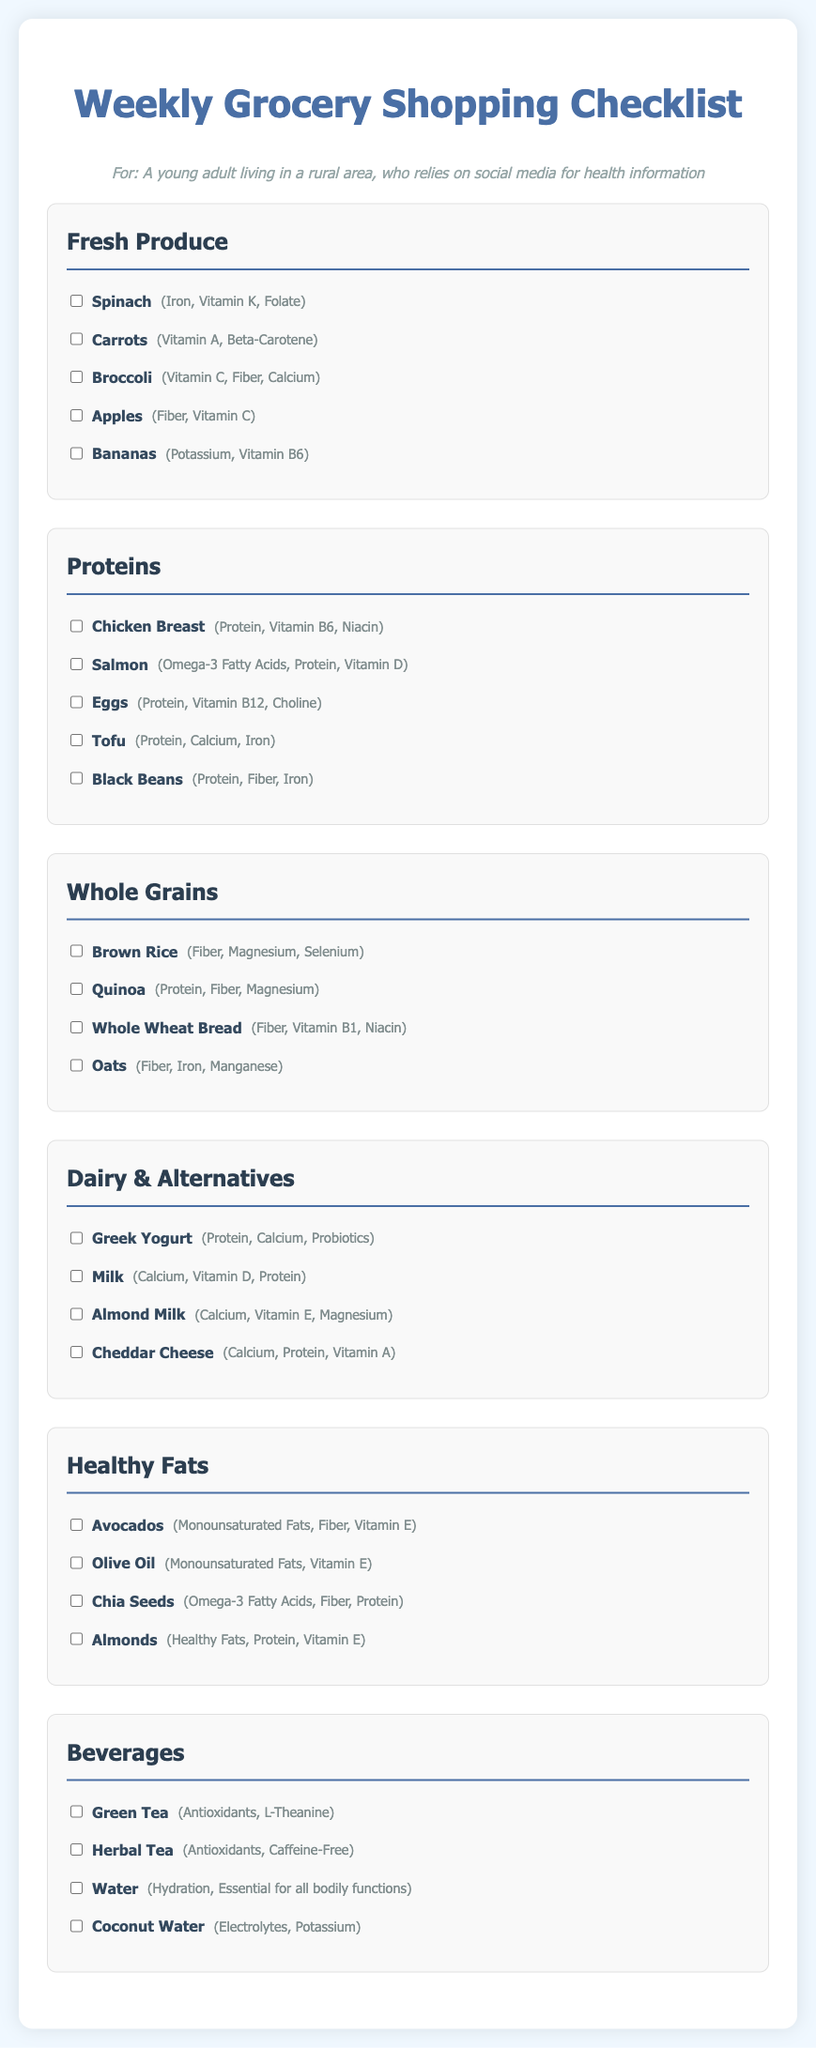What items are listed under Fresh Produce? The Fresh Produce section lists spinach, carrots, broccoli, apples, and bananas.
Answer: Spinach, carrots, broccoli, apples, bananas How many types of proteins are included in the checklist? There are five types of proteins listed: chicken breast, salmon, eggs, tofu, and black beans.
Answer: Five What nutrient is found in bananas? The nutrient found in bananas is potassium and Vitamin B6.
Answer: Potassium, Vitamin B6 Which healthy fat is mentioned that is also a fruit? The healthy fat mentioned that is also a fruit is avocado.
Answer: Avocado What is the purpose of including beverages in this checklist? The beverages included are meant for hydration and providing essential nutrients like antioxidants.
Answer: Hydration, antioxidants How many items are there in the Dairy & Alternatives section? The Dairy & Alternatives section includes four items: Greek yogurt, milk, almond milk, and cheddar cheese.
Answer: Four What type of food is quinoa categorized under? Quinoa is categorized under Whole Grains.
Answer: Whole Grains Which item is listed as a source of Omega-3 fatty acids in the Proteins section? Salmon is listed as a source of Omega-3 fatty acids in the Proteins section.
Answer: Salmon Which beverage is described as caffeine-free? Herbal tea is described as caffeine-free.
Answer: Herbal Tea 